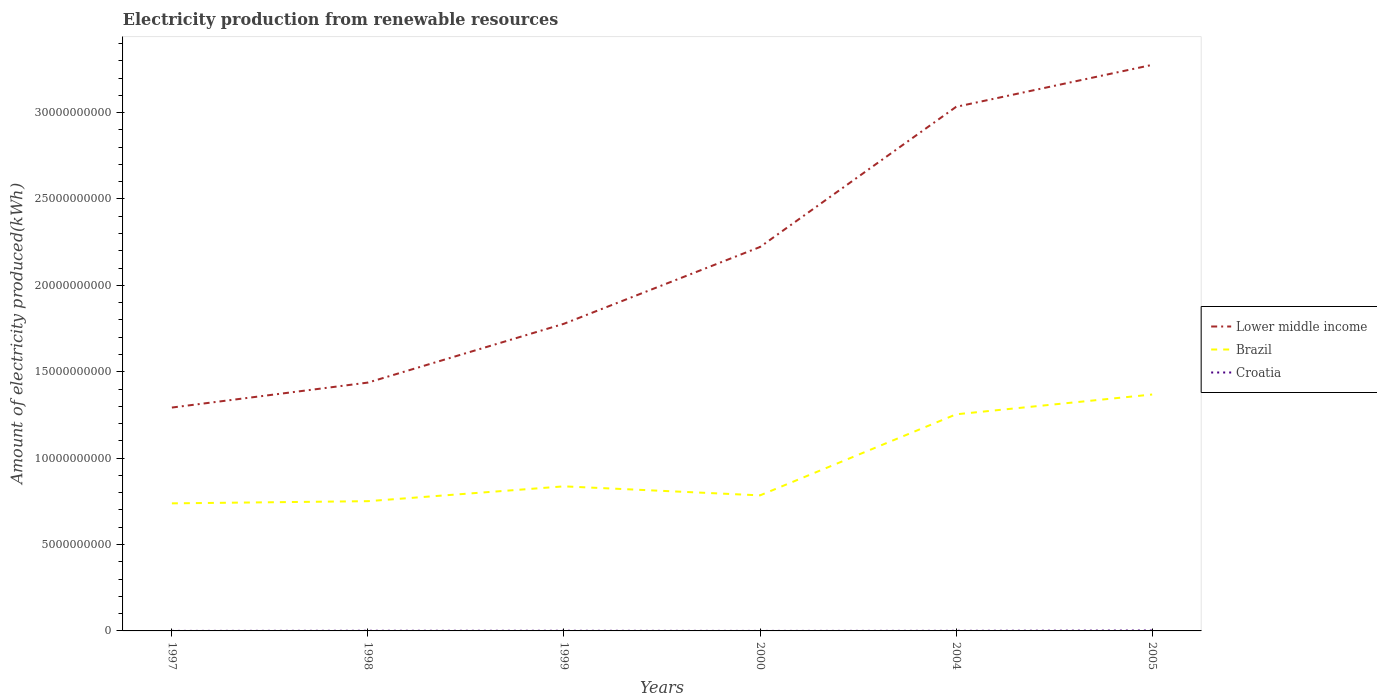How many different coloured lines are there?
Ensure brevity in your answer.  3. Does the line corresponding to Lower middle income intersect with the line corresponding to Croatia?
Keep it short and to the point. No. Across all years, what is the maximum amount of electricity produced in Lower middle income?
Your answer should be very brief. 1.29e+1. In which year was the amount of electricity produced in Brazil maximum?
Give a very brief answer. 1997. What is the total amount of electricity produced in Croatia in the graph?
Ensure brevity in your answer.  -8.00e+06. What is the difference between the highest and the second highest amount of electricity produced in Lower middle income?
Make the answer very short. 1.98e+1. Is the amount of electricity produced in Croatia strictly greater than the amount of electricity produced in Lower middle income over the years?
Give a very brief answer. Yes. How many lines are there?
Keep it short and to the point. 3. What is the difference between two consecutive major ticks on the Y-axis?
Give a very brief answer. 5.00e+09. Are the values on the major ticks of Y-axis written in scientific E-notation?
Give a very brief answer. No. Does the graph contain grids?
Your response must be concise. No. What is the title of the graph?
Your answer should be compact. Electricity production from renewable resources. Does "Trinidad and Tobago" appear as one of the legend labels in the graph?
Your answer should be compact. No. What is the label or title of the Y-axis?
Ensure brevity in your answer.  Amount of electricity produced(kWh). What is the Amount of electricity produced(kWh) of Lower middle income in 1997?
Your answer should be very brief. 1.29e+1. What is the Amount of electricity produced(kWh) in Brazil in 1997?
Ensure brevity in your answer.  7.38e+09. What is the Amount of electricity produced(kWh) of Croatia in 1997?
Ensure brevity in your answer.  1.00e+06. What is the Amount of electricity produced(kWh) in Lower middle income in 1998?
Keep it short and to the point. 1.44e+1. What is the Amount of electricity produced(kWh) of Brazil in 1998?
Offer a terse response. 7.51e+09. What is the Amount of electricity produced(kWh) of Croatia in 1998?
Keep it short and to the point. 9.00e+06. What is the Amount of electricity produced(kWh) of Lower middle income in 1999?
Keep it short and to the point. 1.78e+1. What is the Amount of electricity produced(kWh) in Brazil in 1999?
Your response must be concise. 8.37e+09. What is the Amount of electricity produced(kWh) of Croatia in 1999?
Give a very brief answer. 9.00e+06. What is the Amount of electricity produced(kWh) in Lower middle income in 2000?
Provide a succinct answer. 2.22e+1. What is the Amount of electricity produced(kWh) of Brazil in 2000?
Offer a terse response. 7.85e+09. What is the Amount of electricity produced(kWh) of Croatia in 2000?
Make the answer very short. 1.00e+06. What is the Amount of electricity produced(kWh) of Lower middle income in 2004?
Provide a succinct answer. 3.03e+1. What is the Amount of electricity produced(kWh) of Brazil in 2004?
Keep it short and to the point. 1.25e+1. What is the Amount of electricity produced(kWh) of Croatia in 2004?
Provide a short and direct response. 6.00e+06. What is the Amount of electricity produced(kWh) of Lower middle income in 2005?
Offer a terse response. 3.28e+1. What is the Amount of electricity produced(kWh) of Brazil in 2005?
Your response must be concise. 1.37e+1. What is the Amount of electricity produced(kWh) in Croatia in 2005?
Your answer should be very brief. 2.40e+07. Across all years, what is the maximum Amount of electricity produced(kWh) of Lower middle income?
Your answer should be compact. 3.28e+1. Across all years, what is the maximum Amount of electricity produced(kWh) of Brazil?
Your answer should be very brief. 1.37e+1. Across all years, what is the maximum Amount of electricity produced(kWh) in Croatia?
Provide a succinct answer. 2.40e+07. Across all years, what is the minimum Amount of electricity produced(kWh) of Lower middle income?
Keep it short and to the point. 1.29e+1. Across all years, what is the minimum Amount of electricity produced(kWh) of Brazil?
Ensure brevity in your answer.  7.38e+09. What is the total Amount of electricity produced(kWh) in Lower middle income in the graph?
Give a very brief answer. 1.30e+11. What is the total Amount of electricity produced(kWh) in Brazil in the graph?
Keep it short and to the point. 5.73e+1. What is the difference between the Amount of electricity produced(kWh) in Lower middle income in 1997 and that in 1998?
Provide a short and direct response. -1.44e+09. What is the difference between the Amount of electricity produced(kWh) of Brazil in 1997 and that in 1998?
Provide a succinct answer. -1.27e+08. What is the difference between the Amount of electricity produced(kWh) in Croatia in 1997 and that in 1998?
Offer a very short reply. -8.00e+06. What is the difference between the Amount of electricity produced(kWh) of Lower middle income in 1997 and that in 1999?
Provide a short and direct response. -4.85e+09. What is the difference between the Amount of electricity produced(kWh) of Brazil in 1997 and that in 1999?
Your response must be concise. -9.85e+08. What is the difference between the Amount of electricity produced(kWh) in Croatia in 1997 and that in 1999?
Offer a very short reply. -8.00e+06. What is the difference between the Amount of electricity produced(kWh) of Lower middle income in 1997 and that in 2000?
Offer a terse response. -9.29e+09. What is the difference between the Amount of electricity produced(kWh) in Brazil in 1997 and that in 2000?
Ensure brevity in your answer.  -4.63e+08. What is the difference between the Amount of electricity produced(kWh) in Lower middle income in 1997 and that in 2004?
Keep it short and to the point. -1.74e+1. What is the difference between the Amount of electricity produced(kWh) of Brazil in 1997 and that in 2004?
Make the answer very short. -5.15e+09. What is the difference between the Amount of electricity produced(kWh) in Croatia in 1997 and that in 2004?
Provide a short and direct response. -5.00e+06. What is the difference between the Amount of electricity produced(kWh) in Lower middle income in 1997 and that in 2005?
Your answer should be very brief. -1.98e+1. What is the difference between the Amount of electricity produced(kWh) in Brazil in 1997 and that in 2005?
Keep it short and to the point. -6.30e+09. What is the difference between the Amount of electricity produced(kWh) in Croatia in 1997 and that in 2005?
Your response must be concise. -2.30e+07. What is the difference between the Amount of electricity produced(kWh) in Lower middle income in 1998 and that in 1999?
Give a very brief answer. -3.40e+09. What is the difference between the Amount of electricity produced(kWh) in Brazil in 1998 and that in 1999?
Provide a succinct answer. -8.58e+08. What is the difference between the Amount of electricity produced(kWh) of Croatia in 1998 and that in 1999?
Keep it short and to the point. 0. What is the difference between the Amount of electricity produced(kWh) in Lower middle income in 1998 and that in 2000?
Ensure brevity in your answer.  -7.85e+09. What is the difference between the Amount of electricity produced(kWh) in Brazil in 1998 and that in 2000?
Make the answer very short. -3.36e+08. What is the difference between the Amount of electricity produced(kWh) of Croatia in 1998 and that in 2000?
Provide a succinct answer. 8.00e+06. What is the difference between the Amount of electricity produced(kWh) in Lower middle income in 1998 and that in 2004?
Keep it short and to the point. -1.60e+1. What is the difference between the Amount of electricity produced(kWh) of Brazil in 1998 and that in 2004?
Your answer should be very brief. -5.03e+09. What is the difference between the Amount of electricity produced(kWh) of Lower middle income in 1998 and that in 2005?
Keep it short and to the point. -1.84e+1. What is the difference between the Amount of electricity produced(kWh) in Brazil in 1998 and that in 2005?
Your answer should be compact. -6.17e+09. What is the difference between the Amount of electricity produced(kWh) in Croatia in 1998 and that in 2005?
Give a very brief answer. -1.50e+07. What is the difference between the Amount of electricity produced(kWh) of Lower middle income in 1999 and that in 2000?
Provide a succinct answer. -4.44e+09. What is the difference between the Amount of electricity produced(kWh) of Brazil in 1999 and that in 2000?
Your answer should be very brief. 5.22e+08. What is the difference between the Amount of electricity produced(kWh) in Croatia in 1999 and that in 2000?
Offer a terse response. 8.00e+06. What is the difference between the Amount of electricity produced(kWh) in Lower middle income in 1999 and that in 2004?
Make the answer very short. -1.26e+1. What is the difference between the Amount of electricity produced(kWh) of Brazil in 1999 and that in 2004?
Ensure brevity in your answer.  -4.17e+09. What is the difference between the Amount of electricity produced(kWh) in Lower middle income in 1999 and that in 2005?
Keep it short and to the point. -1.50e+1. What is the difference between the Amount of electricity produced(kWh) in Brazil in 1999 and that in 2005?
Make the answer very short. -5.32e+09. What is the difference between the Amount of electricity produced(kWh) in Croatia in 1999 and that in 2005?
Offer a very short reply. -1.50e+07. What is the difference between the Amount of electricity produced(kWh) of Lower middle income in 2000 and that in 2004?
Provide a succinct answer. -8.11e+09. What is the difference between the Amount of electricity produced(kWh) of Brazil in 2000 and that in 2004?
Make the answer very short. -4.69e+09. What is the difference between the Amount of electricity produced(kWh) in Croatia in 2000 and that in 2004?
Your answer should be compact. -5.00e+06. What is the difference between the Amount of electricity produced(kWh) in Lower middle income in 2000 and that in 2005?
Keep it short and to the point. -1.05e+1. What is the difference between the Amount of electricity produced(kWh) of Brazil in 2000 and that in 2005?
Give a very brief answer. -5.84e+09. What is the difference between the Amount of electricity produced(kWh) in Croatia in 2000 and that in 2005?
Your answer should be compact. -2.30e+07. What is the difference between the Amount of electricity produced(kWh) of Lower middle income in 2004 and that in 2005?
Keep it short and to the point. -2.43e+09. What is the difference between the Amount of electricity produced(kWh) of Brazil in 2004 and that in 2005?
Offer a terse response. -1.15e+09. What is the difference between the Amount of electricity produced(kWh) in Croatia in 2004 and that in 2005?
Provide a short and direct response. -1.80e+07. What is the difference between the Amount of electricity produced(kWh) of Lower middle income in 1997 and the Amount of electricity produced(kWh) of Brazil in 1998?
Provide a succinct answer. 5.42e+09. What is the difference between the Amount of electricity produced(kWh) of Lower middle income in 1997 and the Amount of electricity produced(kWh) of Croatia in 1998?
Offer a terse response. 1.29e+1. What is the difference between the Amount of electricity produced(kWh) in Brazil in 1997 and the Amount of electricity produced(kWh) in Croatia in 1998?
Make the answer very short. 7.37e+09. What is the difference between the Amount of electricity produced(kWh) in Lower middle income in 1997 and the Amount of electricity produced(kWh) in Brazil in 1999?
Your response must be concise. 4.56e+09. What is the difference between the Amount of electricity produced(kWh) of Lower middle income in 1997 and the Amount of electricity produced(kWh) of Croatia in 1999?
Provide a succinct answer. 1.29e+1. What is the difference between the Amount of electricity produced(kWh) in Brazil in 1997 and the Amount of electricity produced(kWh) in Croatia in 1999?
Offer a terse response. 7.37e+09. What is the difference between the Amount of electricity produced(kWh) in Lower middle income in 1997 and the Amount of electricity produced(kWh) in Brazil in 2000?
Offer a very short reply. 5.08e+09. What is the difference between the Amount of electricity produced(kWh) in Lower middle income in 1997 and the Amount of electricity produced(kWh) in Croatia in 2000?
Give a very brief answer. 1.29e+1. What is the difference between the Amount of electricity produced(kWh) of Brazil in 1997 and the Amount of electricity produced(kWh) of Croatia in 2000?
Ensure brevity in your answer.  7.38e+09. What is the difference between the Amount of electricity produced(kWh) in Lower middle income in 1997 and the Amount of electricity produced(kWh) in Brazil in 2004?
Provide a succinct answer. 3.92e+08. What is the difference between the Amount of electricity produced(kWh) in Lower middle income in 1997 and the Amount of electricity produced(kWh) in Croatia in 2004?
Keep it short and to the point. 1.29e+1. What is the difference between the Amount of electricity produced(kWh) in Brazil in 1997 and the Amount of electricity produced(kWh) in Croatia in 2004?
Give a very brief answer. 7.38e+09. What is the difference between the Amount of electricity produced(kWh) in Lower middle income in 1997 and the Amount of electricity produced(kWh) in Brazil in 2005?
Offer a terse response. -7.55e+08. What is the difference between the Amount of electricity produced(kWh) in Lower middle income in 1997 and the Amount of electricity produced(kWh) in Croatia in 2005?
Provide a succinct answer. 1.29e+1. What is the difference between the Amount of electricity produced(kWh) in Brazil in 1997 and the Amount of electricity produced(kWh) in Croatia in 2005?
Your answer should be very brief. 7.36e+09. What is the difference between the Amount of electricity produced(kWh) in Lower middle income in 1998 and the Amount of electricity produced(kWh) in Brazil in 1999?
Provide a succinct answer. 6.01e+09. What is the difference between the Amount of electricity produced(kWh) in Lower middle income in 1998 and the Amount of electricity produced(kWh) in Croatia in 1999?
Provide a succinct answer. 1.44e+1. What is the difference between the Amount of electricity produced(kWh) in Brazil in 1998 and the Amount of electricity produced(kWh) in Croatia in 1999?
Your response must be concise. 7.50e+09. What is the difference between the Amount of electricity produced(kWh) of Lower middle income in 1998 and the Amount of electricity produced(kWh) of Brazil in 2000?
Your answer should be very brief. 6.53e+09. What is the difference between the Amount of electricity produced(kWh) in Lower middle income in 1998 and the Amount of electricity produced(kWh) in Croatia in 2000?
Make the answer very short. 1.44e+1. What is the difference between the Amount of electricity produced(kWh) of Brazil in 1998 and the Amount of electricity produced(kWh) of Croatia in 2000?
Your response must be concise. 7.51e+09. What is the difference between the Amount of electricity produced(kWh) of Lower middle income in 1998 and the Amount of electricity produced(kWh) of Brazil in 2004?
Your answer should be very brief. 1.84e+09. What is the difference between the Amount of electricity produced(kWh) of Lower middle income in 1998 and the Amount of electricity produced(kWh) of Croatia in 2004?
Keep it short and to the point. 1.44e+1. What is the difference between the Amount of electricity produced(kWh) in Brazil in 1998 and the Amount of electricity produced(kWh) in Croatia in 2004?
Your answer should be very brief. 7.50e+09. What is the difference between the Amount of electricity produced(kWh) in Lower middle income in 1998 and the Amount of electricity produced(kWh) in Brazil in 2005?
Keep it short and to the point. 6.90e+08. What is the difference between the Amount of electricity produced(kWh) of Lower middle income in 1998 and the Amount of electricity produced(kWh) of Croatia in 2005?
Offer a terse response. 1.44e+1. What is the difference between the Amount of electricity produced(kWh) of Brazil in 1998 and the Amount of electricity produced(kWh) of Croatia in 2005?
Offer a terse response. 7.49e+09. What is the difference between the Amount of electricity produced(kWh) in Lower middle income in 1999 and the Amount of electricity produced(kWh) in Brazil in 2000?
Keep it short and to the point. 9.93e+09. What is the difference between the Amount of electricity produced(kWh) of Lower middle income in 1999 and the Amount of electricity produced(kWh) of Croatia in 2000?
Offer a terse response. 1.78e+1. What is the difference between the Amount of electricity produced(kWh) in Brazil in 1999 and the Amount of electricity produced(kWh) in Croatia in 2000?
Offer a very short reply. 8.37e+09. What is the difference between the Amount of electricity produced(kWh) of Lower middle income in 1999 and the Amount of electricity produced(kWh) of Brazil in 2004?
Offer a very short reply. 5.24e+09. What is the difference between the Amount of electricity produced(kWh) in Lower middle income in 1999 and the Amount of electricity produced(kWh) in Croatia in 2004?
Offer a terse response. 1.78e+1. What is the difference between the Amount of electricity produced(kWh) in Brazil in 1999 and the Amount of electricity produced(kWh) in Croatia in 2004?
Offer a very short reply. 8.36e+09. What is the difference between the Amount of electricity produced(kWh) in Lower middle income in 1999 and the Amount of electricity produced(kWh) in Brazil in 2005?
Provide a short and direct response. 4.10e+09. What is the difference between the Amount of electricity produced(kWh) in Lower middle income in 1999 and the Amount of electricity produced(kWh) in Croatia in 2005?
Offer a terse response. 1.78e+1. What is the difference between the Amount of electricity produced(kWh) in Brazil in 1999 and the Amount of electricity produced(kWh) in Croatia in 2005?
Your answer should be very brief. 8.34e+09. What is the difference between the Amount of electricity produced(kWh) in Lower middle income in 2000 and the Amount of electricity produced(kWh) in Brazil in 2004?
Give a very brief answer. 9.68e+09. What is the difference between the Amount of electricity produced(kWh) in Lower middle income in 2000 and the Amount of electricity produced(kWh) in Croatia in 2004?
Offer a very short reply. 2.22e+1. What is the difference between the Amount of electricity produced(kWh) of Brazil in 2000 and the Amount of electricity produced(kWh) of Croatia in 2004?
Provide a succinct answer. 7.84e+09. What is the difference between the Amount of electricity produced(kWh) of Lower middle income in 2000 and the Amount of electricity produced(kWh) of Brazil in 2005?
Provide a succinct answer. 8.54e+09. What is the difference between the Amount of electricity produced(kWh) of Lower middle income in 2000 and the Amount of electricity produced(kWh) of Croatia in 2005?
Provide a short and direct response. 2.22e+1. What is the difference between the Amount of electricity produced(kWh) in Brazil in 2000 and the Amount of electricity produced(kWh) in Croatia in 2005?
Offer a terse response. 7.82e+09. What is the difference between the Amount of electricity produced(kWh) of Lower middle income in 2004 and the Amount of electricity produced(kWh) of Brazil in 2005?
Ensure brevity in your answer.  1.66e+1. What is the difference between the Amount of electricity produced(kWh) in Lower middle income in 2004 and the Amount of electricity produced(kWh) in Croatia in 2005?
Make the answer very short. 3.03e+1. What is the difference between the Amount of electricity produced(kWh) in Brazil in 2004 and the Amount of electricity produced(kWh) in Croatia in 2005?
Your response must be concise. 1.25e+1. What is the average Amount of electricity produced(kWh) of Lower middle income per year?
Make the answer very short. 2.17e+1. What is the average Amount of electricity produced(kWh) of Brazil per year?
Provide a succinct answer. 9.55e+09. What is the average Amount of electricity produced(kWh) of Croatia per year?
Provide a short and direct response. 8.33e+06. In the year 1997, what is the difference between the Amount of electricity produced(kWh) in Lower middle income and Amount of electricity produced(kWh) in Brazil?
Your answer should be very brief. 5.55e+09. In the year 1997, what is the difference between the Amount of electricity produced(kWh) in Lower middle income and Amount of electricity produced(kWh) in Croatia?
Your response must be concise. 1.29e+1. In the year 1997, what is the difference between the Amount of electricity produced(kWh) in Brazil and Amount of electricity produced(kWh) in Croatia?
Your answer should be very brief. 7.38e+09. In the year 1998, what is the difference between the Amount of electricity produced(kWh) in Lower middle income and Amount of electricity produced(kWh) in Brazil?
Provide a short and direct response. 6.86e+09. In the year 1998, what is the difference between the Amount of electricity produced(kWh) in Lower middle income and Amount of electricity produced(kWh) in Croatia?
Provide a short and direct response. 1.44e+1. In the year 1998, what is the difference between the Amount of electricity produced(kWh) of Brazil and Amount of electricity produced(kWh) of Croatia?
Your answer should be compact. 7.50e+09. In the year 1999, what is the difference between the Amount of electricity produced(kWh) of Lower middle income and Amount of electricity produced(kWh) of Brazil?
Your answer should be very brief. 9.41e+09. In the year 1999, what is the difference between the Amount of electricity produced(kWh) in Lower middle income and Amount of electricity produced(kWh) in Croatia?
Ensure brevity in your answer.  1.78e+1. In the year 1999, what is the difference between the Amount of electricity produced(kWh) in Brazil and Amount of electricity produced(kWh) in Croatia?
Offer a terse response. 8.36e+09. In the year 2000, what is the difference between the Amount of electricity produced(kWh) in Lower middle income and Amount of electricity produced(kWh) in Brazil?
Offer a very short reply. 1.44e+1. In the year 2000, what is the difference between the Amount of electricity produced(kWh) of Lower middle income and Amount of electricity produced(kWh) of Croatia?
Your response must be concise. 2.22e+1. In the year 2000, what is the difference between the Amount of electricity produced(kWh) in Brazil and Amount of electricity produced(kWh) in Croatia?
Your response must be concise. 7.84e+09. In the year 2004, what is the difference between the Amount of electricity produced(kWh) in Lower middle income and Amount of electricity produced(kWh) in Brazil?
Ensure brevity in your answer.  1.78e+1. In the year 2004, what is the difference between the Amount of electricity produced(kWh) in Lower middle income and Amount of electricity produced(kWh) in Croatia?
Offer a very short reply. 3.03e+1. In the year 2004, what is the difference between the Amount of electricity produced(kWh) in Brazil and Amount of electricity produced(kWh) in Croatia?
Give a very brief answer. 1.25e+1. In the year 2005, what is the difference between the Amount of electricity produced(kWh) of Lower middle income and Amount of electricity produced(kWh) of Brazil?
Your answer should be very brief. 1.91e+1. In the year 2005, what is the difference between the Amount of electricity produced(kWh) of Lower middle income and Amount of electricity produced(kWh) of Croatia?
Provide a succinct answer. 3.27e+1. In the year 2005, what is the difference between the Amount of electricity produced(kWh) in Brazil and Amount of electricity produced(kWh) in Croatia?
Ensure brevity in your answer.  1.37e+1. What is the ratio of the Amount of electricity produced(kWh) of Lower middle income in 1997 to that in 1998?
Make the answer very short. 0.9. What is the ratio of the Amount of electricity produced(kWh) in Brazil in 1997 to that in 1998?
Make the answer very short. 0.98. What is the ratio of the Amount of electricity produced(kWh) of Croatia in 1997 to that in 1998?
Give a very brief answer. 0.11. What is the ratio of the Amount of electricity produced(kWh) in Lower middle income in 1997 to that in 1999?
Your response must be concise. 0.73. What is the ratio of the Amount of electricity produced(kWh) of Brazil in 1997 to that in 1999?
Make the answer very short. 0.88. What is the ratio of the Amount of electricity produced(kWh) in Lower middle income in 1997 to that in 2000?
Your response must be concise. 0.58. What is the ratio of the Amount of electricity produced(kWh) of Brazil in 1997 to that in 2000?
Keep it short and to the point. 0.94. What is the ratio of the Amount of electricity produced(kWh) of Croatia in 1997 to that in 2000?
Ensure brevity in your answer.  1. What is the ratio of the Amount of electricity produced(kWh) of Lower middle income in 1997 to that in 2004?
Provide a succinct answer. 0.43. What is the ratio of the Amount of electricity produced(kWh) in Brazil in 1997 to that in 2004?
Provide a succinct answer. 0.59. What is the ratio of the Amount of electricity produced(kWh) in Croatia in 1997 to that in 2004?
Ensure brevity in your answer.  0.17. What is the ratio of the Amount of electricity produced(kWh) in Lower middle income in 1997 to that in 2005?
Your answer should be very brief. 0.39. What is the ratio of the Amount of electricity produced(kWh) of Brazil in 1997 to that in 2005?
Offer a very short reply. 0.54. What is the ratio of the Amount of electricity produced(kWh) in Croatia in 1997 to that in 2005?
Provide a short and direct response. 0.04. What is the ratio of the Amount of electricity produced(kWh) of Lower middle income in 1998 to that in 1999?
Keep it short and to the point. 0.81. What is the ratio of the Amount of electricity produced(kWh) in Brazil in 1998 to that in 1999?
Provide a short and direct response. 0.9. What is the ratio of the Amount of electricity produced(kWh) in Croatia in 1998 to that in 1999?
Provide a short and direct response. 1. What is the ratio of the Amount of electricity produced(kWh) in Lower middle income in 1998 to that in 2000?
Offer a very short reply. 0.65. What is the ratio of the Amount of electricity produced(kWh) in Brazil in 1998 to that in 2000?
Make the answer very short. 0.96. What is the ratio of the Amount of electricity produced(kWh) of Croatia in 1998 to that in 2000?
Provide a succinct answer. 9. What is the ratio of the Amount of electricity produced(kWh) of Lower middle income in 1998 to that in 2004?
Provide a short and direct response. 0.47. What is the ratio of the Amount of electricity produced(kWh) of Brazil in 1998 to that in 2004?
Provide a short and direct response. 0.6. What is the ratio of the Amount of electricity produced(kWh) of Croatia in 1998 to that in 2004?
Your response must be concise. 1.5. What is the ratio of the Amount of electricity produced(kWh) in Lower middle income in 1998 to that in 2005?
Ensure brevity in your answer.  0.44. What is the ratio of the Amount of electricity produced(kWh) of Brazil in 1998 to that in 2005?
Keep it short and to the point. 0.55. What is the ratio of the Amount of electricity produced(kWh) of Croatia in 1998 to that in 2005?
Offer a terse response. 0.38. What is the ratio of the Amount of electricity produced(kWh) in Lower middle income in 1999 to that in 2000?
Your response must be concise. 0.8. What is the ratio of the Amount of electricity produced(kWh) in Brazil in 1999 to that in 2000?
Provide a succinct answer. 1.07. What is the ratio of the Amount of electricity produced(kWh) in Croatia in 1999 to that in 2000?
Keep it short and to the point. 9. What is the ratio of the Amount of electricity produced(kWh) of Lower middle income in 1999 to that in 2004?
Provide a short and direct response. 0.59. What is the ratio of the Amount of electricity produced(kWh) in Brazil in 1999 to that in 2004?
Your answer should be very brief. 0.67. What is the ratio of the Amount of electricity produced(kWh) of Croatia in 1999 to that in 2004?
Your answer should be compact. 1.5. What is the ratio of the Amount of electricity produced(kWh) in Lower middle income in 1999 to that in 2005?
Give a very brief answer. 0.54. What is the ratio of the Amount of electricity produced(kWh) of Brazil in 1999 to that in 2005?
Provide a succinct answer. 0.61. What is the ratio of the Amount of electricity produced(kWh) of Croatia in 1999 to that in 2005?
Your answer should be compact. 0.38. What is the ratio of the Amount of electricity produced(kWh) in Lower middle income in 2000 to that in 2004?
Offer a very short reply. 0.73. What is the ratio of the Amount of electricity produced(kWh) in Brazil in 2000 to that in 2004?
Your answer should be compact. 0.63. What is the ratio of the Amount of electricity produced(kWh) in Lower middle income in 2000 to that in 2005?
Provide a short and direct response. 0.68. What is the ratio of the Amount of electricity produced(kWh) in Brazil in 2000 to that in 2005?
Ensure brevity in your answer.  0.57. What is the ratio of the Amount of electricity produced(kWh) of Croatia in 2000 to that in 2005?
Provide a short and direct response. 0.04. What is the ratio of the Amount of electricity produced(kWh) in Lower middle income in 2004 to that in 2005?
Ensure brevity in your answer.  0.93. What is the ratio of the Amount of electricity produced(kWh) in Brazil in 2004 to that in 2005?
Your response must be concise. 0.92. What is the difference between the highest and the second highest Amount of electricity produced(kWh) in Lower middle income?
Ensure brevity in your answer.  2.43e+09. What is the difference between the highest and the second highest Amount of electricity produced(kWh) of Brazil?
Provide a succinct answer. 1.15e+09. What is the difference between the highest and the second highest Amount of electricity produced(kWh) of Croatia?
Provide a short and direct response. 1.50e+07. What is the difference between the highest and the lowest Amount of electricity produced(kWh) of Lower middle income?
Offer a terse response. 1.98e+1. What is the difference between the highest and the lowest Amount of electricity produced(kWh) of Brazil?
Provide a short and direct response. 6.30e+09. What is the difference between the highest and the lowest Amount of electricity produced(kWh) of Croatia?
Offer a very short reply. 2.30e+07. 